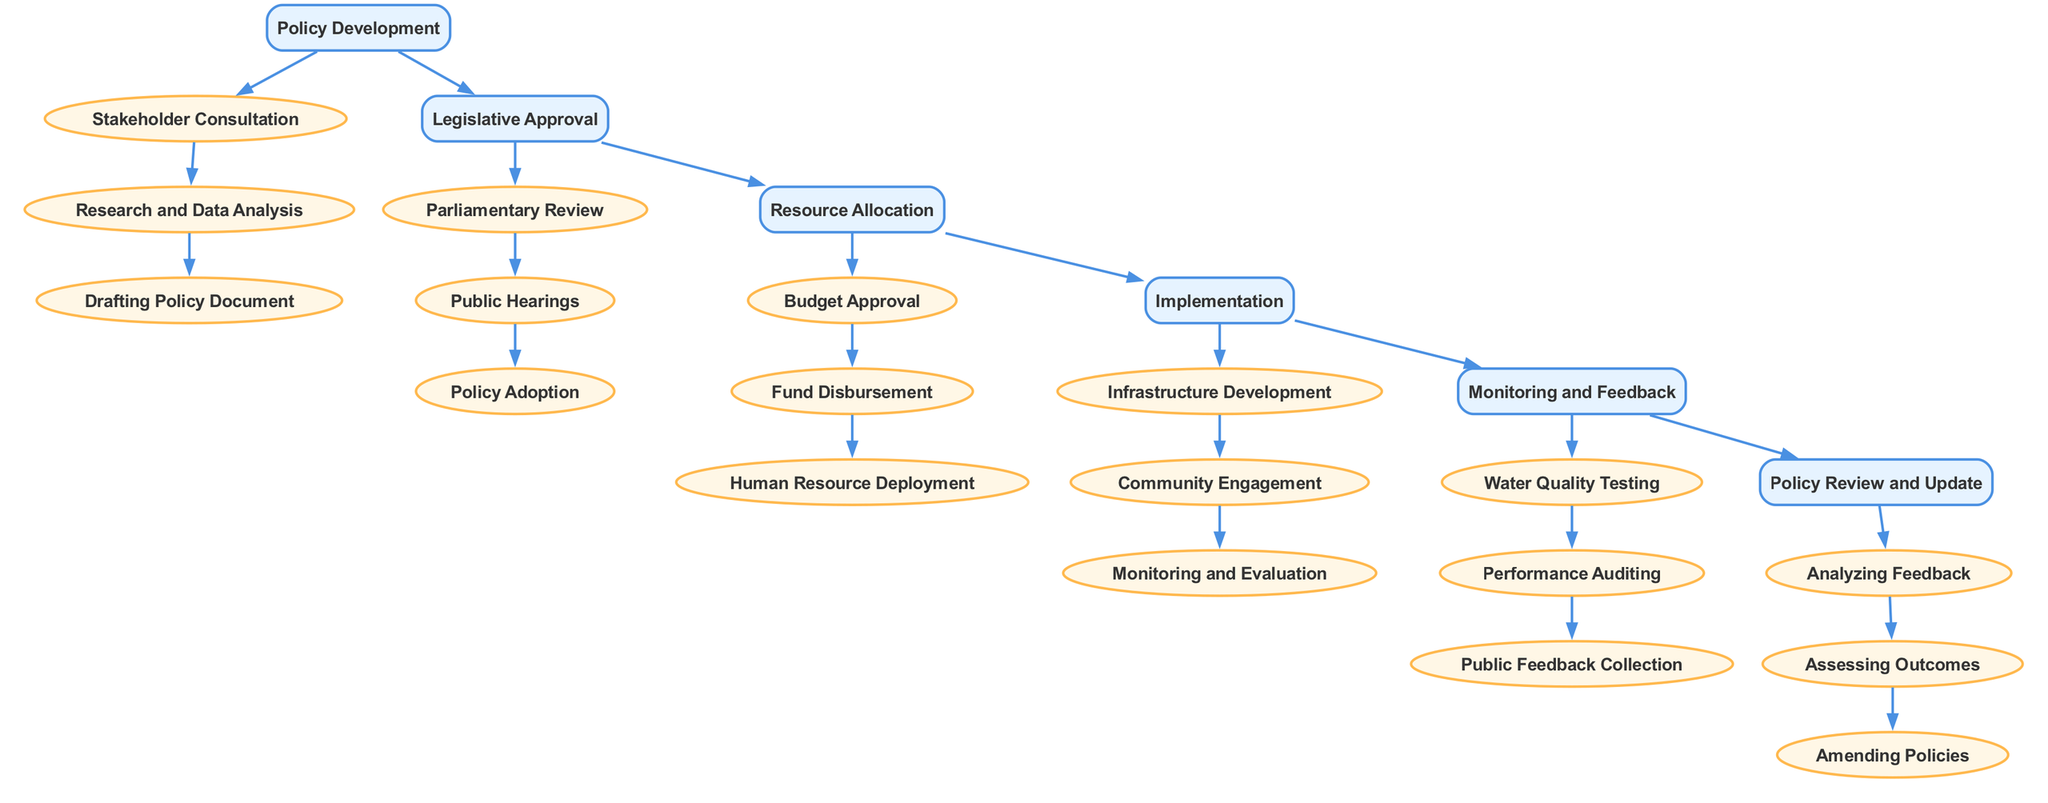What is the first step in the policy implementation process? The diagram indicates that the first step in the policy implementation process is "Policy Development." This is evident as the first node in the diagram.
Answer: Policy Development How many main elements are there in the diagram? The diagram comprises six main elements, with each represented as a distinct node in the flow of the policy implementation process.
Answer: 6 What connects "Resource Allocation" and "Implementation" in the diagram? The connection between "Resource Allocation" and "Implementation" is specifically represented by a directed edge that denotes the flow from one main element to another in the policy implementation sequence.
Answer: Implementation Which sub-element follows "Public Hearings"? According to the diagram, "Public Hearings" is followed by the sub-element "Policy Adoption" under the "Legislative Approval" section of the policy implementation process.
Answer: Policy Adoption What is the last main element in the sequence? The last main element in the sequence, as shown in the diagram, is "Policy Review and Update." This marks the final stage of the process.
Answer: Policy Review and Update How many sub-elements does "Implementation" have? The "Implementation" node has three sub-elements listed in the diagram: "Infrastructure Development," "Community Engagement," and "Monitoring and Evaluation."
Answer: 3 Which sub-element precedes "Water Quality Testing"? "Water Quality Testing" is preceded by its parent node "Monitoring and Feedback," which indicates the order of actions within that main element in the policy implementation diagram.
Answer: Monitoring and Feedback What is the relationship between "Legislative Approval" and "Policy Development"? The relationship between "Legislative Approval" and "Policy Development" is that "Legislative Approval" follows "Policy Development" in the policy implementation process, as indicated by the directed edge connecting the two main elements.
Answer: Follows What three components are included in "Monitoring and Feedback"? The "Monitoring and Feedback" section includes the components "Water Quality Testing," "Performance Auditing," and "Public Feedback Collection," as visualized in the diagram.
Answer: Water Quality Testing, Performance Auditing, Public Feedback Collection 